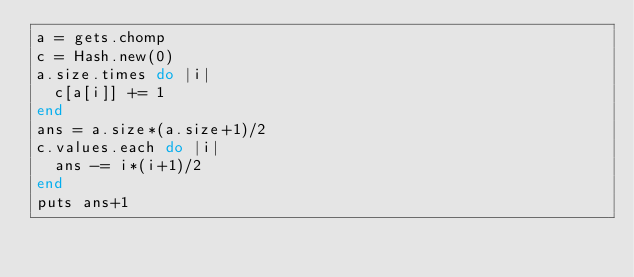<code> <loc_0><loc_0><loc_500><loc_500><_Ruby_>a = gets.chomp
c = Hash.new(0)
a.size.times do |i|
  c[a[i]] += 1
end
ans = a.size*(a.size+1)/2
c.values.each do |i|
  ans -= i*(i+1)/2
end
puts ans+1</code> 